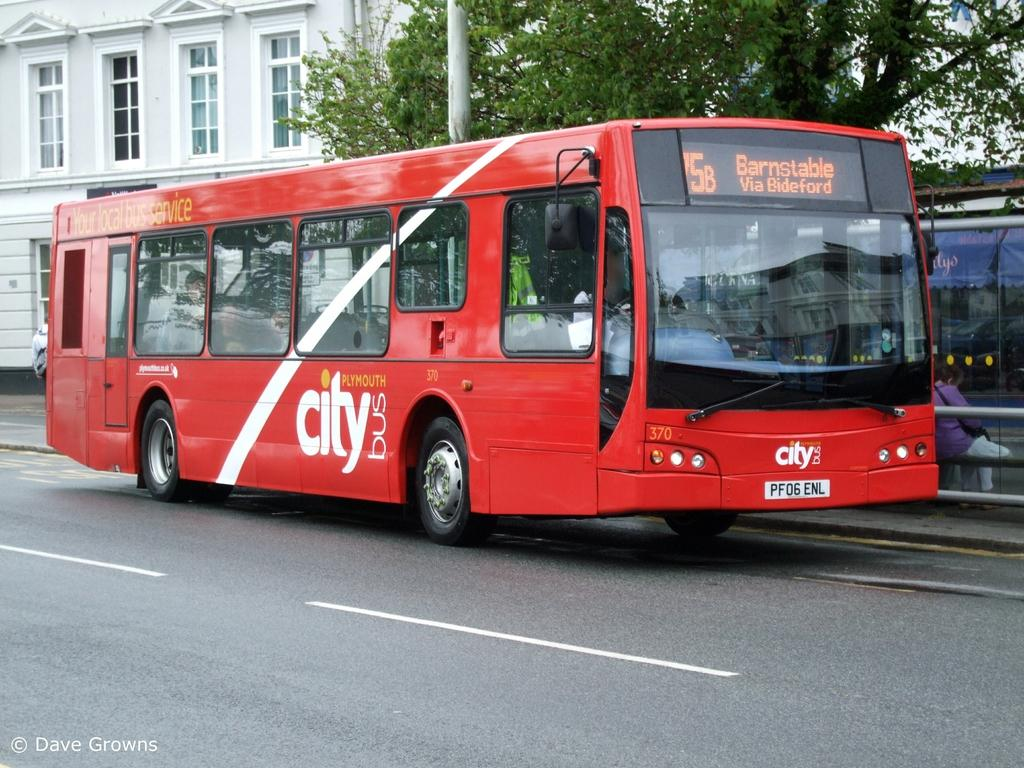<image>
Offer a succinct explanation of the picture presented. The bus has the phrase "Your local bus service" painted on the top left side of the bus. 